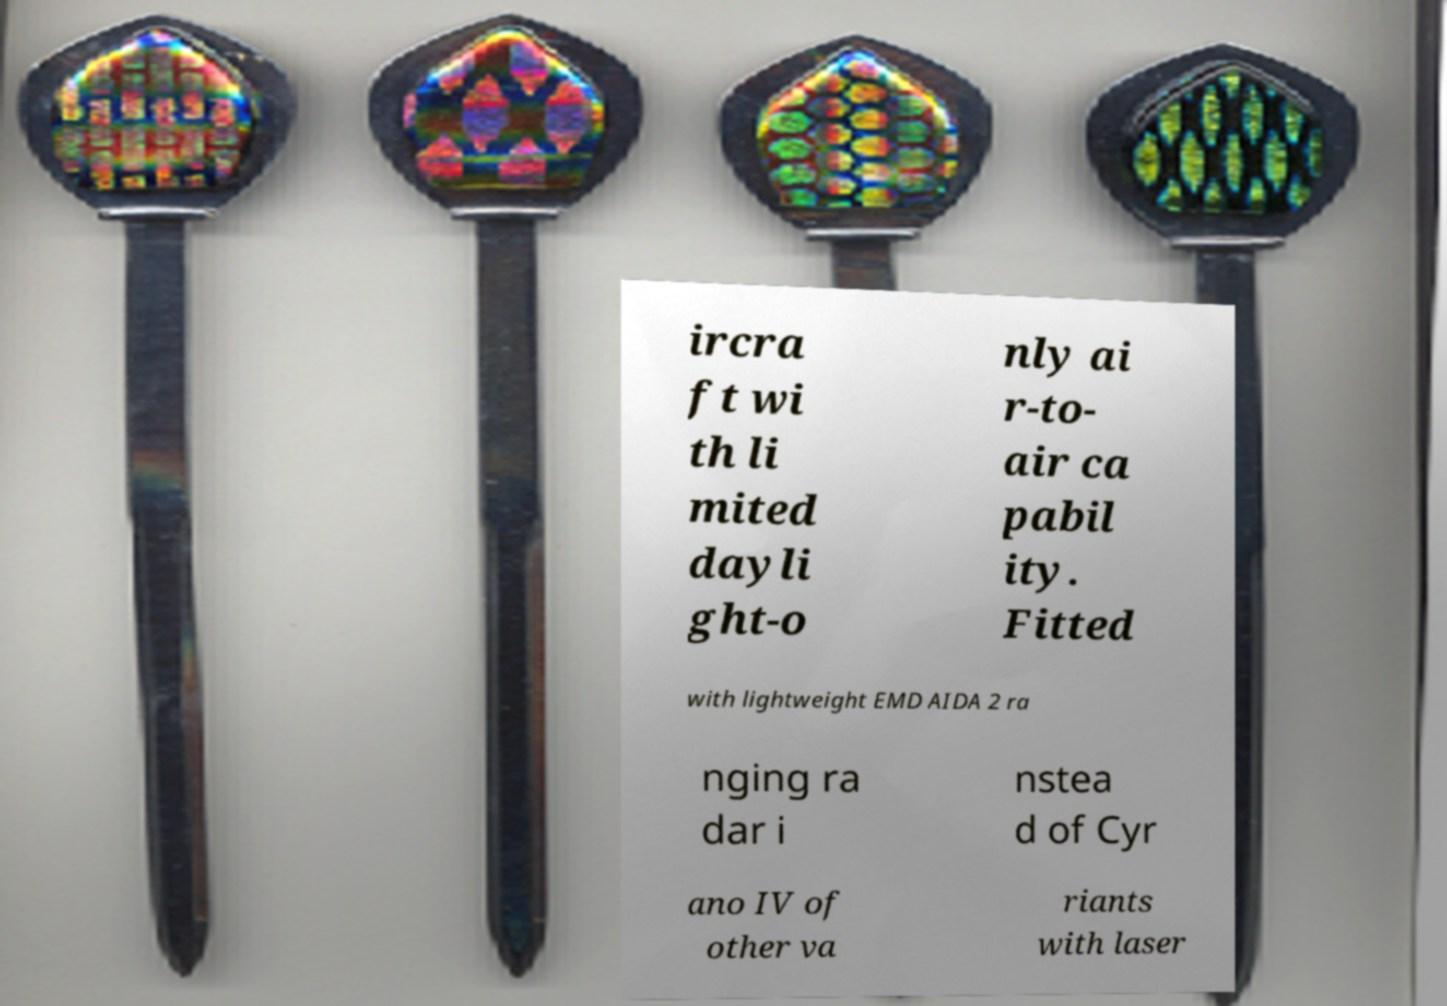Can you read and provide the text displayed in the image?This photo seems to have some interesting text. Can you extract and type it out for me? ircra ft wi th li mited dayli ght-o nly ai r-to- air ca pabil ity. Fitted with lightweight EMD AIDA 2 ra nging ra dar i nstea d of Cyr ano IV of other va riants with laser 